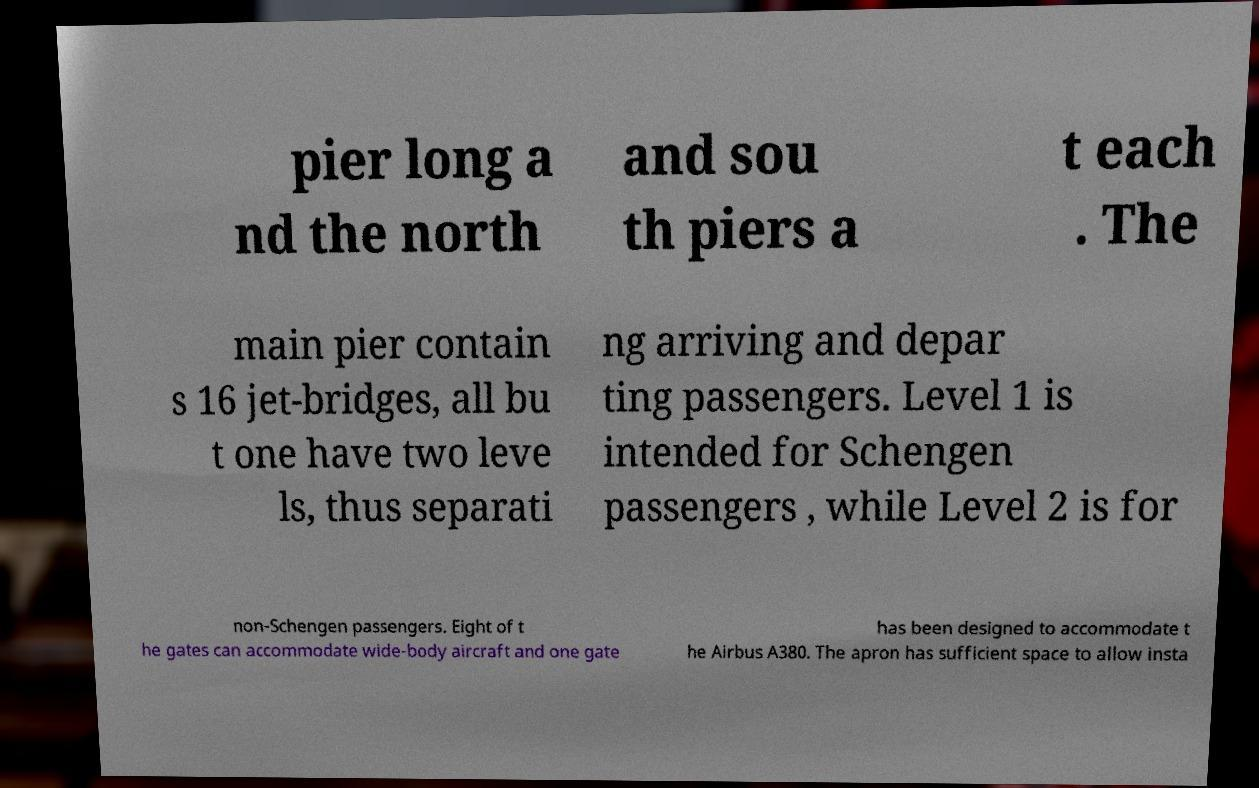What messages or text are displayed in this image? I need them in a readable, typed format. pier long a nd the north and sou th piers a t each . The main pier contain s 16 jet-bridges, all bu t one have two leve ls, thus separati ng arriving and depar ting passengers. Level 1 is intended for Schengen passengers , while Level 2 is for non-Schengen passengers. Eight of t he gates can accommodate wide-body aircraft and one gate has been designed to accommodate t he Airbus A380. The apron has sufficient space to allow insta 